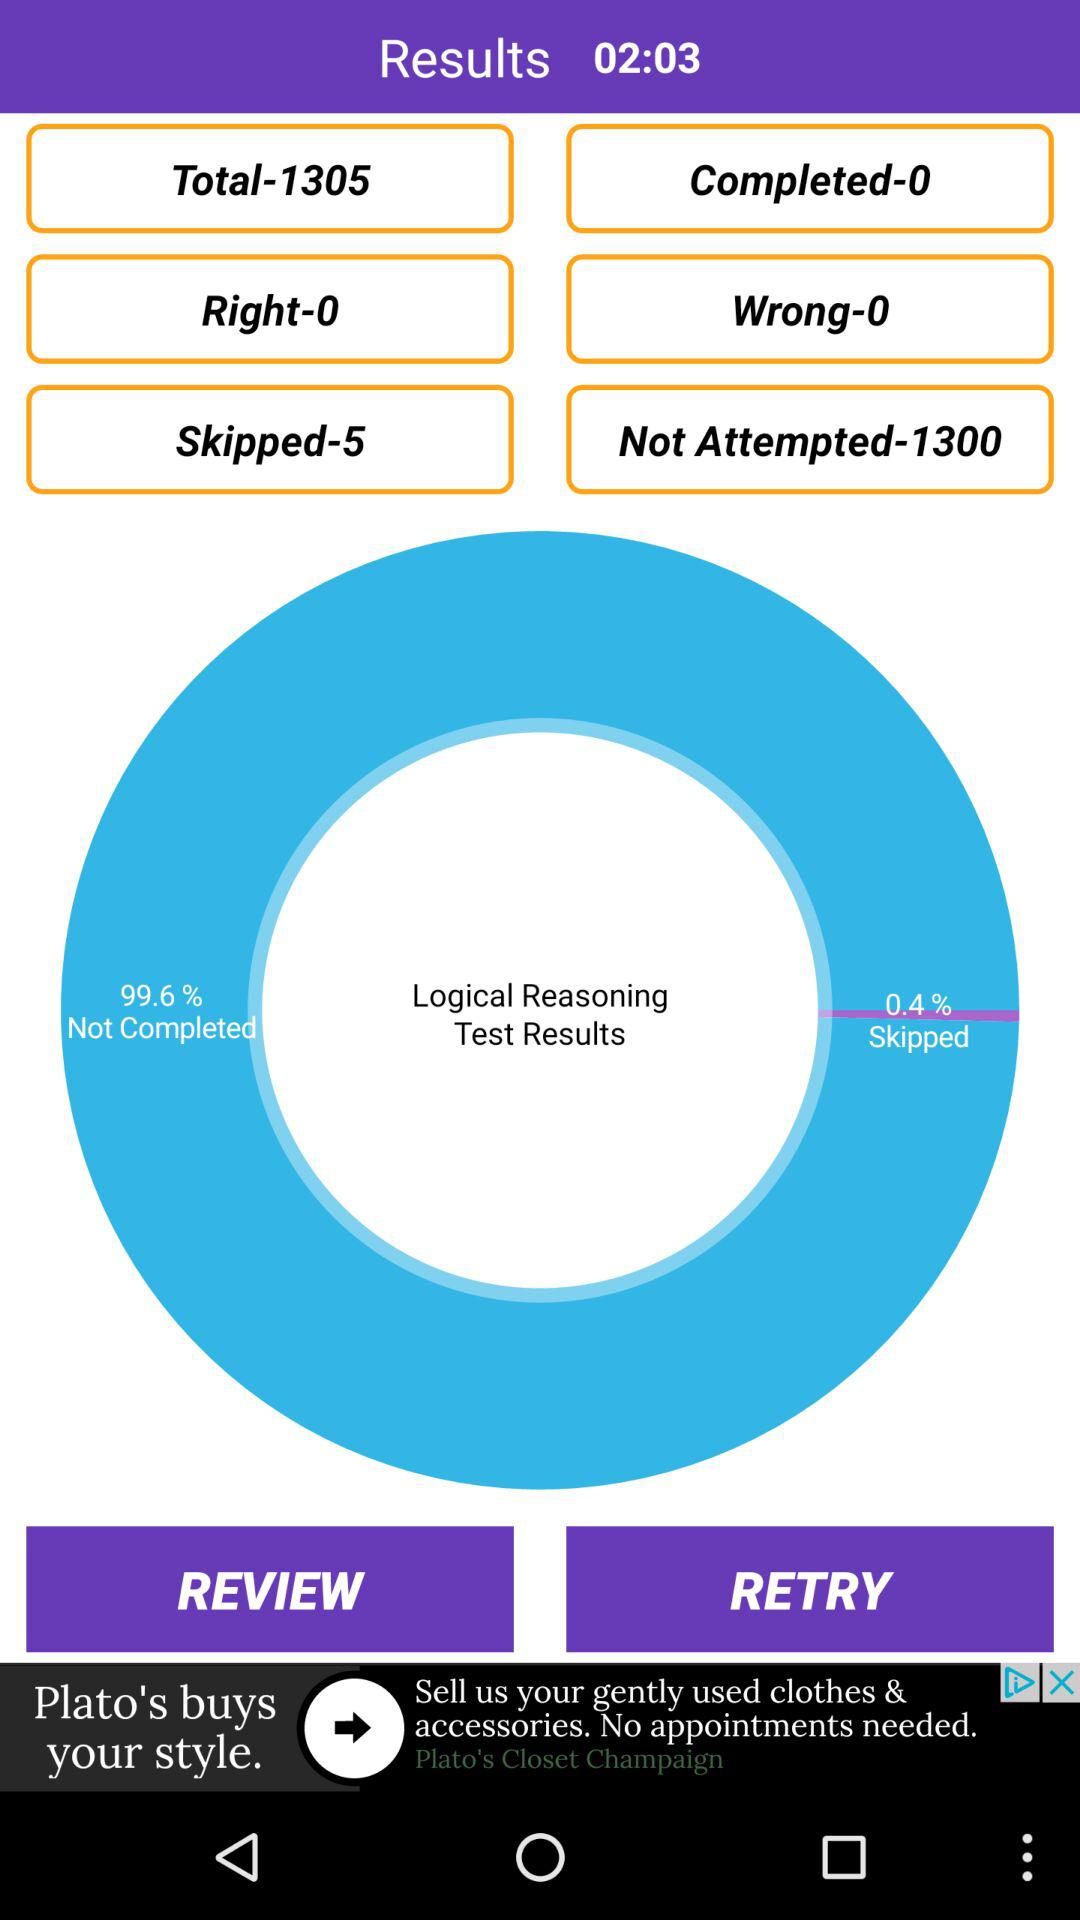What percentage of the logical reasoning test results are not completed? The percentage is 99.6. 